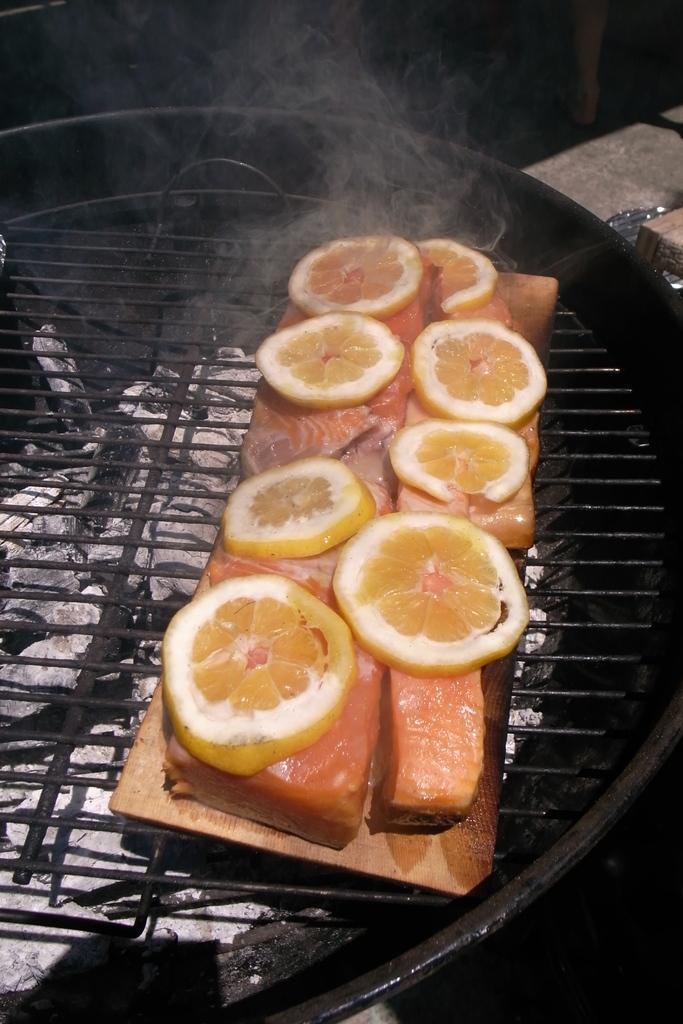How would you summarize this image in a sentence or two? In this image we can see some food. There is some liquid in the utensil. There are some reflections on the surface of the liquid. There is some smoke in the image. 